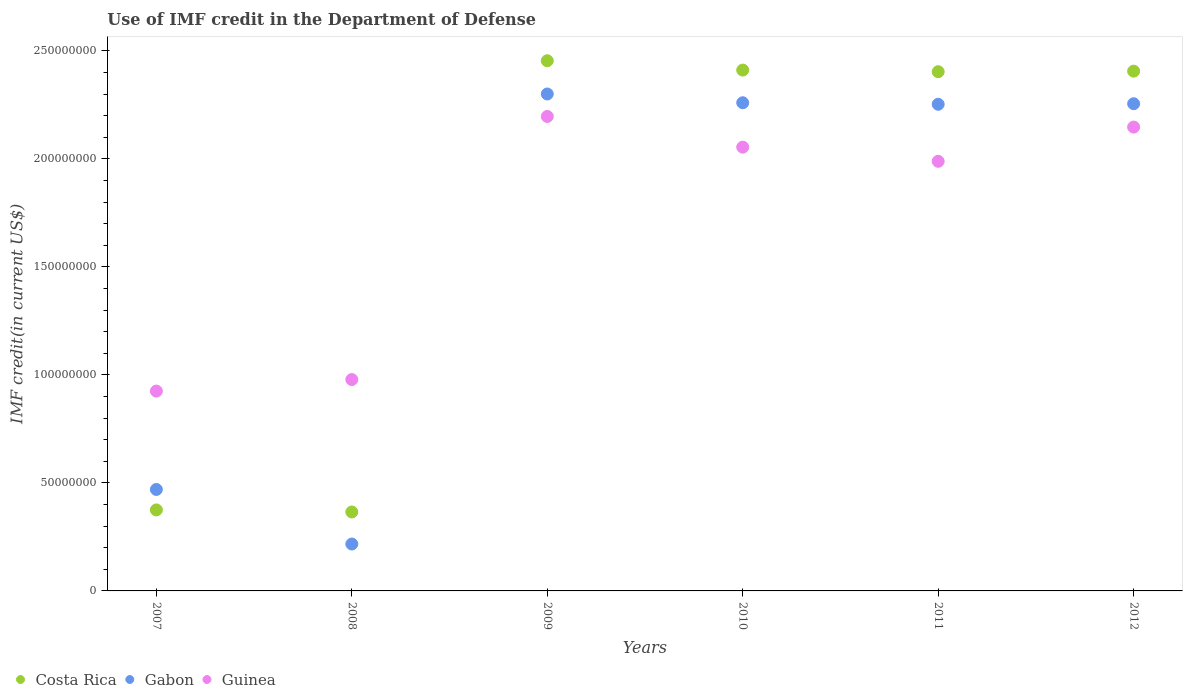What is the IMF credit in the Department of Defense in Gabon in 2011?
Provide a succinct answer. 2.25e+08. Across all years, what is the maximum IMF credit in the Department of Defense in Guinea?
Ensure brevity in your answer.  2.20e+08. Across all years, what is the minimum IMF credit in the Department of Defense in Guinea?
Give a very brief answer. 9.25e+07. What is the total IMF credit in the Department of Defense in Guinea in the graph?
Your answer should be compact. 1.03e+09. What is the difference between the IMF credit in the Department of Defense in Costa Rica in 2008 and that in 2009?
Your answer should be very brief. -2.09e+08. What is the difference between the IMF credit in the Department of Defense in Gabon in 2010 and the IMF credit in the Department of Defense in Costa Rica in 2008?
Offer a terse response. 1.89e+08. What is the average IMF credit in the Department of Defense in Guinea per year?
Your response must be concise. 1.71e+08. In the year 2009, what is the difference between the IMF credit in the Department of Defense in Gabon and IMF credit in the Department of Defense in Guinea?
Your response must be concise. 1.04e+07. In how many years, is the IMF credit in the Department of Defense in Costa Rica greater than 220000000 US$?
Keep it short and to the point. 4. What is the ratio of the IMF credit in the Department of Defense in Guinea in 2007 to that in 2011?
Ensure brevity in your answer.  0.47. Is the IMF credit in the Department of Defense in Costa Rica in 2008 less than that in 2009?
Make the answer very short. Yes. What is the difference between the highest and the second highest IMF credit in the Department of Defense in Guinea?
Your response must be concise. 4.92e+06. What is the difference between the highest and the lowest IMF credit in the Department of Defense in Costa Rica?
Provide a succinct answer. 2.09e+08. Is the sum of the IMF credit in the Department of Defense in Guinea in 2008 and 2010 greater than the maximum IMF credit in the Department of Defense in Gabon across all years?
Offer a very short reply. Yes. Does the IMF credit in the Department of Defense in Guinea monotonically increase over the years?
Provide a short and direct response. No. How many dotlines are there?
Provide a short and direct response. 3. Are the values on the major ticks of Y-axis written in scientific E-notation?
Keep it short and to the point. No. What is the title of the graph?
Provide a short and direct response. Use of IMF credit in the Department of Defense. Does "North America" appear as one of the legend labels in the graph?
Provide a short and direct response. No. What is the label or title of the Y-axis?
Give a very brief answer. IMF credit(in current US$). What is the IMF credit(in current US$) in Costa Rica in 2007?
Provide a short and direct response. 3.75e+07. What is the IMF credit(in current US$) in Gabon in 2007?
Keep it short and to the point. 4.70e+07. What is the IMF credit(in current US$) of Guinea in 2007?
Keep it short and to the point. 9.25e+07. What is the IMF credit(in current US$) in Costa Rica in 2008?
Your response must be concise. 3.65e+07. What is the IMF credit(in current US$) of Gabon in 2008?
Your answer should be very brief. 2.17e+07. What is the IMF credit(in current US$) in Guinea in 2008?
Make the answer very short. 9.78e+07. What is the IMF credit(in current US$) of Costa Rica in 2009?
Make the answer very short. 2.45e+08. What is the IMF credit(in current US$) in Gabon in 2009?
Offer a terse response. 2.30e+08. What is the IMF credit(in current US$) of Guinea in 2009?
Your answer should be compact. 2.20e+08. What is the IMF credit(in current US$) of Costa Rica in 2010?
Offer a terse response. 2.41e+08. What is the IMF credit(in current US$) of Gabon in 2010?
Make the answer very short. 2.26e+08. What is the IMF credit(in current US$) in Guinea in 2010?
Ensure brevity in your answer.  2.05e+08. What is the IMF credit(in current US$) of Costa Rica in 2011?
Ensure brevity in your answer.  2.40e+08. What is the IMF credit(in current US$) in Gabon in 2011?
Provide a short and direct response. 2.25e+08. What is the IMF credit(in current US$) in Guinea in 2011?
Make the answer very short. 1.99e+08. What is the IMF credit(in current US$) in Costa Rica in 2012?
Your answer should be very brief. 2.41e+08. What is the IMF credit(in current US$) of Gabon in 2012?
Ensure brevity in your answer.  2.25e+08. What is the IMF credit(in current US$) of Guinea in 2012?
Your answer should be very brief. 2.15e+08. Across all years, what is the maximum IMF credit(in current US$) in Costa Rica?
Make the answer very short. 2.45e+08. Across all years, what is the maximum IMF credit(in current US$) of Gabon?
Give a very brief answer. 2.30e+08. Across all years, what is the maximum IMF credit(in current US$) in Guinea?
Your answer should be compact. 2.20e+08. Across all years, what is the minimum IMF credit(in current US$) of Costa Rica?
Your answer should be compact. 3.65e+07. Across all years, what is the minimum IMF credit(in current US$) of Gabon?
Make the answer very short. 2.17e+07. Across all years, what is the minimum IMF credit(in current US$) in Guinea?
Make the answer very short. 9.25e+07. What is the total IMF credit(in current US$) of Costa Rica in the graph?
Your answer should be very brief. 1.04e+09. What is the total IMF credit(in current US$) in Gabon in the graph?
Offer a terse response. 9.75e+08. What is the total IMF credit(in current US$) in Guinea in the graph?
Ensure brevity in your answer.  1.03e+09. What is the difference between the IMF credit(in current US$) in Costa Rica in 2007 and that in 2008?
Your response must be concise. 9.49e+05. What is the difference between the IMF credit(in current US$) in Gabon in 2007 and that in 2008?
Provide a short and direct response. 2.53e+07. What is the difference between the IMF credit(in current US$) of Guinea in 2007 and that in 2008?
Ensure brevity in your answer.  -5.33e+06. What is the difference between the IMF credit(in current US$) in Costa Rica in 2007 and that in 2009?
Keep it short and to the point. -2.08e+08. What is the difference between the IMF credit(in current US$) in Gabon in 2007 and that in 2009?
Ensure brevity in your answer.  -1.83e+08. What is the difference between the IMF credit(in current US$) of Guinea in 2007 and that in 2009?
Ensure brevity in your answer.  -1.27e+08. What is the difference between the IMF credit(in current US$) of Costa Rica in 2007 and that in 2010?
Keep it short and to the point. -2.04e+08. What is the difference between the IMF credit(in current US$) of Gabon in 2007 and that in 2010?
Keep it short and to the point. -1.79e+08. What is the difference between the IMF credit(in current US$) in Guinea in 2007 and that in 2010?
Offer a terse response. -1.13e+08. What is the difference between the IMF credit(in current US$) in Costa Rica in 2007 and that in 2011?
Make the answer very short. -2.03e+08. What is the difference between the IMF credit(in current US$) of Gabon in 2007 and that in 2011?
Offer a terse response. -1.78e+08. What is the difference between the IMF credit(in current US$) of Guinea in 2007 and that in 2011?
Keep it short and to the point. -1.06e+08. What is the difference between the IMF credit(in current US$) in Costa Rica in 2007 and that in 2012?
Offer a very short reply. -2.03e+08. What is the difference between the IMF credit(in current US$) of Gabon in 2007 and that in 2012?
Offer a terse response. -1.79e+08. What is the difference between the IMF credit(in current US$) in Guinea in 2007 and that in 2012?
Ensure brevity in your answer.  -1.22e+08. What is the difference between the IMF credit(in current US$) in Costa Rica in 2008 and that in 2009?
Your answer should be compact. -2.09e+08. What is the difference between the IMF credit(in current US$) of Gabon in 2008 and that in 2009?
Give a very brief answer. -2.08e+08. What is the difference between the IMF credit(in current US$) in Guinea in 2008 and that in 2009?
Your answer should be very brief. -1.22e+08. What is the difference between the IMF credit(in current US$) in Costa Rica in 2008 and that in 2010?
Give a very brief answer. -2.05e+08. What is the difference between the IMF credit(in current US$) of Gabon in 2008 and that in 2010?
Give a very brief answer. -2.04e+08. What is the difference between the IMF credit(in current US$) of Guinea in 2008 and that in 2010?
Your answer should be very brief. -1.08e+08. What is the difference between the IMF credit(in current US$) in Costa Rica in 2008 and that in 2011?
Provide a short and direct response. -2.04e+08. What is the difference between the IMF credit(in current US$) in Gabon in 2008 and that in 2011?
Make the answer very short. -2.04e+08. What is the difference between the IMF credit(in current US$) in Guinea in 2008 and that in 2011?
Ensure brevity in your answer.  -1.01e+08. What is the difference between the IMF credit(in current US$) in Costa Rica in 2008 and that in 2012?
Your answer should be compact. -2.04e+08. What is the difference between the IMF credit(in current US$) of Gabon in 2008 and that in 2012?
Keep it short and to the point. -2.04e+08. What is the difference between the IMF credit(in current US$) of Guinea in 2008 and that in 2012?
Provide a succinct answer. -1.17e+08. What is the difference between the IMF credit(in current US$) of Costa Rica in 2009 and that in 2010?
Your response must be concise. 4.33e+06. What is the difference between the IMF credit(in current US$) in Gabon in 2009 and that in 2010?
Provide a short and direct response. 4.06e+06. What is the difference between the IMF credit(in current US$) in Guinea in 2009 and that in 2010?
Offer a very short reply. 1.42e+07. What is the difference between the IMF credit(in current US$) in Costa Rica in 2009 and that in 2011?
Offer a terse response. 5.08e+06. What is the difference between the IMF credit(in current US$) in Gabon in 2009 and that in 2011?
Ensure brevity in your answer.  4.76e+06. What is the difference between the IMF credit(in current US$) of Guinea in 2009 and that in 2011?
Offer a very short reply. 2.08e+07. What is the difference between the IMF credit(in current US$) of Costa Rica in 2009 and that in 2012?
Your answer should be compact. 4.82e+06. What is the difference between the IMF credit(in current US$) of Gabon in 2009 and that in 2012?
Your response must be concise. 4.52e+06. What is the difference between the IMF credit(in current US$) in Guinea in 2009 and that in 2012?
Ensure brevity in your answer.  4.92e+06. What is the difference between the IMF credit(in current US$) in Costa Rica in 2010 and that in 2011?
Provide a short and direct response. 7.45e+05. What is the difference between the IMF credit(in current US$) of Gabon in 2010 and that in 2011?
Ensure brevity in your answer.  6.98e+05. What is the difference between the IMF credit(in current US$) in Guinea in 2010 and that in 2011?
Provide a short and direct response. 6.55e+06. What is the difference between the IMF credit(in current US$) in Costa Rica in 2010 and that in 2012?
Your answer should be very brief. 4.87e+05. What is the difference between the IMF credit(in current US$) in Gabon in 2010 and that in 2012?
Your response must be concise. 4.56e+05. What is the difference between the IMF credit(in current US$) in Guinea in 2010 and that in 2012?
Provide a short and direct response. -9.30e+06. What is the difference between the IMF credit(in current US$) of Costa Rica in 2011 and that in 2012?
Offer a very short reply. -2.58e+05. What is the difference between the IMF credit(in current US$) of Gabon in 2011 and that in 2012?
Your response must be concise. -2.42e+05. What is the difference between the IMF credit(in current US$) of Guinea in 2011 and that in 2012?
Ensure brevity in your answer.  -1.59e+07. What is the difference between the IMF credit(in current US$) of Costa Rica in 2007 and the IMF credit(in current US$) of Gabon in 2008?
Ensure brevity in your answer.  1.58e+07. What is the difference between the IMF credit(in current US$) of Costa Rica in 2007 and the IMF credit(in current US$) of Guinea in 2008?
Provide a succinct answer. -6.03e+07. What is the difference between the IMF credit(in current US$) in Gabon in 2007 and the IMF credit(in current US$) in Guinea in 2008?
Ensure brevity in your answer.  -5.09e+07. What is the difference between the IMF credit(in current US$) in Costa Rica in 2007 and the IMF credit(in current US$) in Gabon in 2009?
Offer a very short reply. -1.93e+08. What is the difference between the IMF credit(in current US$) of Costa Rica in 2007 and the IMF credit(in current US$) of Guinea in 2009?
Offer a terse response. -1.82e+08. What is the difference between the IMF credit(in current US$) in Gabon in 2007 and the IMF credit(in current US$) in Guinea in 2009?
Your response must be concise. -1.73e+08. What is the difference between the IMF credit(in current US$) in Costa Rica in 2007 and the IMF credit(in current US$) in Gabon in 2010?
Your answer should be compact. -1.88e+08. What is the difference between the IMF credit(in current US$) of Costa Rica in 2007 and the IMF credit(in current US$) of Guinea in 2010?
Offer a very short reply. -1.68e+08. What is the difference between the IMF credit(in current US$) in Gabon in 2007 and the IMF credit(in current US$) in Guinea in 2010?
Your answer should be very brief. -1.58e+08. What is the difference between the IMF credit(in current US$) of Costa Rica in 2007 and the IMF credit(in current US$) of Gabon in 2011?
Provide a succinct answer. -1.88e+08. What is the difference between the IMF credit(in current US$) of Costa Rica in 2007 and the IMF credit(in current US$) of Guinea in 2011?
Offer a very short reply. -1.61e+08. What is the difference between the IMF credit(in current US$) of Gabon in 2007 and the IMF credit(in current US$) of Guinea in 2011?
Your response must be concise. -1.52e+08. What is the difference between the IMF credit(in current US$) in Costa Rica in 2007 and the IMF credit(in current US$) in Gabon in 2012?
Provide a succinct answer. -1.88e+08. What is the difference between the IMF credit(in current US$) of Costa Rica in 2007 and the IMF credit(in current US$) of Guinea in 2012?
Ensure brevity in your answer.  -1.77e+08. What is the difference between the IMF credit(in current US$) of Gabon in 2007 and the IMF credit(in current US$) of Guinea in 2012?
Ensure brevity in your answer.  -1.68e+08. What is the difference between the IMF credit(in current US$) in Costa Rica in 2008 and the IMF credit(in current US$) in Gabon in 2009?
Provide a short and direct response. -1.93e+08. What is the difference between the IMF credit(in current US$) of Costa Rica in 2008 and the IMF credit(in current US$) of Guinea in 2009?
Provide a short and direct response. -1.83e+08. What is the difference between the IMF credit(in current US$) of Gabon in 2008 and the IMF credit(in current US$) of Guinea in 2009?
Give a very brief answer. -1.98e+08. What is the difference between the IMF credit(in current US$) in Costa Rica in 2008 and the IMF credit(in current US$) in Gabon in 2010?
Provide a succinct answer. -1.89e+08. What is the difference between the IMF credit(in current US$) of Costa Rica in 2008 and the IMF credit(in current US$) of Guinea in 2010?
Your response must be concise. -1.69e+08. What is the difference between the IMF credit(in current US$) in Gabon in 2008 and the IMF credit(in current US$) in Guinea in 2010?
Provide a short and direct response. -1.84e+08. What is the difference between the IMF credit(in current US$) in Costa Rica in 2008 and the IMF credit(in current US$) in Gabon in 2011?
Offer a very short reply. -1.89e+08. What is the difference between the IMF credit(in current US$) in Costa Rica in 2008 and the IMF credit(in current US$) in Guinea in 2011?
Ensure brevity in your answer.  -1.62e+08. What is the difference between the IMF credit(in current US$) of Gabon in 2008 and the IMF credit(in current US$) of Guinea in 2011?
Make the answer very short. -1.77e+08. What is the difference between the IMF credit(in current US$) in Costa Rica in 2008 and the IMF credit(in current US$) in Gabon in 2012?
Your answer should be compact. -1.89e+08. What is the difference between the IMF credit(in current US$) in Costa Rica in 2008 and the IMF credit(in current US$) in Guinea in 2012?
Make the answer very short. -1.78e+08. What is the difference between the IMF credit(in current US$) of Gabon in 2008 and the IMF credit(in current US$) of Guinea in 2012?
Ensure brevity in your answer.  -1.93e+08. What is the difference between the IMF credit(in current US$) in Costa Rica in 2009 and the IMF credit(in current US$) in Gabon in 2010?
Provide a short and direct response. 1.94e+07. What is the difference between the IMF credit(in current US$) of Costa Rica in 2009 and the IMF credit(in current US$) of Guinea in 2010?
Provide a succinct answer. 4.00e+07. What is the difference between the IMF credit(in current US$) in Gabon in 2009 and the IMF credit(in current US$) in Guinea in 2010?
Your answer should be compact. 2.46e+07. What is the difference between the IMF credit(in current US$) of Costa Rica in 2009 and the IMF credit(in current US$) of Gabon in 2011?
Offer a very short reply. 2.01e+07. What is the difference between the IMF credit(in current US$) of Costa Rica in 2009 and the IMF credit(in current US$) of Guinea in 2011?
Ensure brevity in your answer.  4.66e+07. What is the difference between the IMF credit(in current US$) in Gabon in 2009 and the IMF credit(in current US$) in Guinea in 2011?
Ensure brevity in your answer.  3.12e+07. What is the difference between the IMF credit(in current US$) in Costa Rica in 2009 and the IMF credit(in current US$) in Gabon in 2012?
Give a very brief answer. 1.99e+07. What is the difference between the IMF credit(in current US$) of Costa Rica in 2009 and the IMF credit(in current US$) of Guinea in 2012?
Make the answer very short. 3.07e+07. What is the difference between the IMF credit(in current US$) of Gabon in 2009 and the IMF credit(in current US$) of Guinea in 2012?
Keep it short and to the point. 1.53e+07. What is the difference between the IMF credit(in current US$) of Costa Rica in 2010 and the IMF credit(in current US$) of Gabon in 2011?
Make the answer very short. 1.58e+07. What is the difference between the IMF credit(in current US$) in Costa Rica in 2010 and the IMF credit(in current US$) in Guinea in 2011?
Keep it short and to the point. 4.22e+07. What is the difference between the IMF credit(in current US$) in Gabon in 2010 and the IMF credit(in current US$) in Guinea in 2011?
Your response must be concise. 2.71e+07. What is the difference between the IMF credit(in current US$) in Costa Rica in 2010 and the IMF credit(in current US$) in Gabon in 2012?
Make the answer very short. 1.56e+07. What is the difference between the IMF credit(in current US$) of Costa Rica in 2010 and the IMF credit(in current US$) of Guinea in 2012?
Your response must be concise. 2.64e+07. What is the difference between the IMF credit(in current US$) in Gabon in 2010 and the IMF credit(in current US$) in Guinea in 2012?
Make the answer very short. 1.13e+07. What is the difference between the IMF credit(in current US$) of Costa Rica in 2011 and the IMF credit(in current US$) of Gabon in 2012?
Give a very brief answer. 1.48e+07. What is the difference between the IMF credit(in current US$) of Costa Rica in 2011 and the IMF credit(in current US$) of Guinea in 2012?
Make the answer very short. 2.56e+07. What is the difference between the IMF credit(in current US$) in Gabon in 2011 and the IMF credit(in current US$) in Guinea in 2012?
Your response must be concise. 1.06e+07. What is the average IMF credit(in current US$) of Costa Rica per year?
Ensure brevity in your answer.  1.74e+08. What is the average IMF credit(in current US$) of Gabon per year?
Keep it short and to the point. 1.63e+08. What is the average IMF credit(in current US$) of Guinea per year?
Provide a succinct answer. 1.71e+08. In the year 2007, what is the difference between the IMF credit(in current US$) of Costa Rica and IMF credit(in current US$) of Gabon?
Your response must be concise. -9.46e+06. In the year 2007, what is the difference between the IMF credit(in current US$) in Costa Rica and IMF credit(in current US$) in Guinea?
Your response must be concise. -5.50e+07. In the year 2007, what is the difference between the IMF credit(in current US$) of Gabon and IMF credit(in current US$) of Guinea?
Provide a short and direct response. -4.55e+07. In the year 2008, what is the difference between the IMF credit(in current US$) in Costa Rica and IMF credit(in current US$) in Gabon?
Keep it short and to the point. 1.48e+07. In the year 2008, what is the difference between the IMF credit(in current US$) of Costa Rica and IMF credit(in current US$) of Guinea?
Provide a short and direct response. -6.13e+07. In the year 2008, what is the difference between the IMF credit(in current US$) in Gabon and IMF credit(in current US$) in Guinea?
Provide a short and direct response. -7.61e+07. In the year 2009, what is the difference between the IMF credit(in current US$) in Costa Rica and IMF credit(in current US$) in Gabon?
Make the answer very short. 1.54e+07. In the year 2009, what is the difference between the IMF credit(in current US$) in Costa Rica and IMF credit(in current US$) in Guinea?
Ensure brevity in your answer.  2.58e+07. In the year 2009, what is the difference between the IMF credit(in current US$) in Gabon and IMF credit(in current US$) in Guinea?
Provide a succinct answer. 1.04e+07. In the year 2010, what is the difference between the IMF credit(in current US$) of Costa Rica and IMF credit(in current US$) of Gabon?
Your response must be concise. 1.51e+07. In the year 2010, what is the difference between the IMF credit(in current US$) in Costa Rica and IMF credit(in current US$) in Guinea?
Provide a succinct answer. 3.57e+07. In the year 2010, what is the difference between the IMF credit(in current US$) in Gabon and IMF credit(in current US$) in Guinea?
Give a very brief answer. 2.06e+07. In the year 2011, what is the difference between the IMF credit(in current US$) in Costa Rica and IMF credit(in current US$) in Gabon?
Offer a terse response. 1.51e+07. In the year 2011, what is the difference between the IMF credit(in current US$) of Costa Rica and IMF credit(in current US$) of Guinea?
Offer a terse response. 4.15e+07. In the year 2011, what is the difference between the IMF credit(in current US$) in Gabon and IMF credit(in current US$) in Guinea?
Your answer should be compact. 2.64e+07. In the year 2012, what is the difference between the IMF credit(in current US$) in Costa Rica and IMF credit(in current US$) in Gabon?
Ensure brevity in your answer.  1.51e+07. In the year 2012, what is the difference between the IMF credit(in current US$) in Costa Rica and IMF credit(in current US$) in Guinea?
Provide a short and direct response. 2.59e+07. In the year 2012, what is the difference between the IMF credit(in current US$) of Gabon and IMF credit(in current US$) of Guinea?
Keep it short and to the point. 1.08e+07. What is the ratio of the IMF credit(in current US$) of Gabon in 2007 to that in 2008?
Offer a very short reply. 2.16. What is the ratio of the IMF credit(in current US$) in Guinea in 2007 to that in 2008?
Offer a very short reply. 0.95. What is the ratio of the IMF credit(in current US$) in Costa Rica in 2007 to that in 2009?
Your answer should be very brief. 0.15. What is the ratio of the IMF credit(in current US$) in Gabon in 2007 to that in 2009?
Provide a succinct answer. 0.2. What is the ratio of the IMF credit(in current US$) in Guinea in 2007 to that in 2009?
Offer a terse response. 0.42. What is the ratio of the IMF credit(in current US$) of Costa Rica in 2007 to that in 2010?
Provide a short and direct response. 0.16. What is the ratio of the IMF credit(in current US$) in Gabon in 2007 to that in 2010?
Keep it short and to the point. 0.21. What is the ratio of the IMF credit(in current US$) of Guinea in 2007 to that in 2010?
Make the answer very short. 0.45. What is the ratio of the IMF credit(in current US$) of Costa Rica in 2007 to that in 2011?
Keep it short and to the point. 0.16. What is the ratio of the IMF credit(in current US$) in Gabon in 2007 to that in 2011?
Ensure brevity in your answer.  0.21. What is the ratio of the IMF credit(in current US$) of Guinea in 2007 to that in 2011?
Provide a succinct answer. 0.47. What is the ratio of the IMF credit(in current US$) of Costa Rica in 2007 to that in 2012?
Keep it short and to the point. 0.16. What is the ratio of the IMF credit(in current US$) in Gabon in 2007 to that in 2012?
Your answer should be compact. 0.21. What is the ratio of the IMF credit(in current US$) in Guinea in 2007 to that in 2012?
Offer a very short reply. 0.43. What is the ratio of the IMF credit(in current US$) of Costa Rica in 2008 to that in 2009?
Provide a short and direct response. 0.15. What is the ratio of the IMF credit(in current US$) of Gabon in 2008 to that in 2009?
Your response must be concise. 0.09. What is the ratio of the IMF credit(in current US$) in Guinea in 2008 to that in 2009?
Your answer should be very brief. 0.45. What is the ratio of the IMF credit(in current US$) in Costa Rica in 2008 to that in 2010?
Provide a short and direct response. 0.15. What is the ratio of the IMF credit(in current US$) in Gabon in 2008 to that in 2010?
Offer a terse response. 0.1. What is the ratio of the IMF credit(in current US$) of Guinea in 2008 to that in 2010?
Offer a very short reply. 0.48. What is the ratio of the IMF credit(in current US$) in Costa Rica in 2008 to that in 2011?
Keep it short and to the point. 0.15. What is the ratio of the IMF credit(in current US$) of Gabon in 2008 to that in 2011?
Your answer should be compact. 0.1. What is the ratio of the IMF credit(in current US$) of Guinea in 2008 to that in 2011?
Keep it short and to the point. 0.49. What is the ratio of the IMF credit(in current US$) in Costa Rica in 2008 to that in 2012?
Your answer should be very brief. 0.15. What is the ratio of the IMF credit(in current US$) of Gabon in 2008 to that in 2012?
Offer a very short reply. 0.1. What is the ratio of the IMF credit(in current US$) in Guinea in 2008 to that in 2012?
Make the answer very short. 0.46. What is the ratio of the IMF credit(in current US$) of Costa Rica in 2009 to that in 2010?
Provide a short and direct response. 1.02. What is the ratio of the IMF credit(in current US$) of Gabon in 2009 to that in 2010?
Provide a succinct answer. 1.02. What is the ratio of the IMF credit(in current US$) in Guinea in 2009 to that in 2010?
Provide a succinct answer. 1.07. What is the ratio of the IMF credit(in current US$) in Costa Rica in 2009 to that in 2011?
Offer a terse response. 1.02. What is the ratio of the IMF credit(in current US$) of Gabon in 2009 to that in 2011?
Your answer should be very brief. 1.02. What is the ratio of the IMF credit(in current US$) of Guinea in 2009 to that in 2011?
Your answer should be compact. 1.1. What is the ratio of the IMF credit(in current US$) of Gabon in 2009 to that in 2012?
Provide a succinct answer. 1.02. What is the ratio of the IMF credit(in current US$) of Guinea in 2009 to that in 2012?
Ensure brevity in your answer.  1.02. What is the ratio of the IMF credit(in current US$) in Gabon in 2010 to that in 2011?
Your response must be concise. 1. What is the ratio of the IMF credit(in current US$) in Guinea in 2010 to that in 2011?
Provide a short and direct response. 1.03. What is the ratio of the IMF credit(in current US$) in Guinea in 2010 to that in 2012?
Offer a very short reply. 0.96. What is the ratio of the IMF credit(in current US$) in Gabon in 2011 to that in 2012?
Give a very brief answer. 1. What is the ratio of the IMF credit(in current US$) in Guinea in 2011 to that in 2012?
Ensure brevity in your answer.  0.93. What is the difference between the highest and the second highest IMF credit(in current US$) in Costa Rica?
Make the answer very short. 4.33e+06. What is the difference between the highest and the second highest IMF credit(in current US$) in Gabon?
Offer a very short reply. 4.06e+06. What is the difference between the highest and the second highest IMF credit(in current US$) of Guinea?
Make the answer very short. 4.92e+06. What is the difference between the highest and the lowest IMF credit(in current US$) of Costa Rica?
Ensure brevity in your answer.  2.09e+08. What is the difference between the highest and the lowest IMF credit(in current US$) in Gabon?
Provide a succinct answer. 2.08e+08. What is the difference between the highest and the lowest IMF credit(in current US$) in Guinea?
Your answer should be compact. 1.27e+08. 